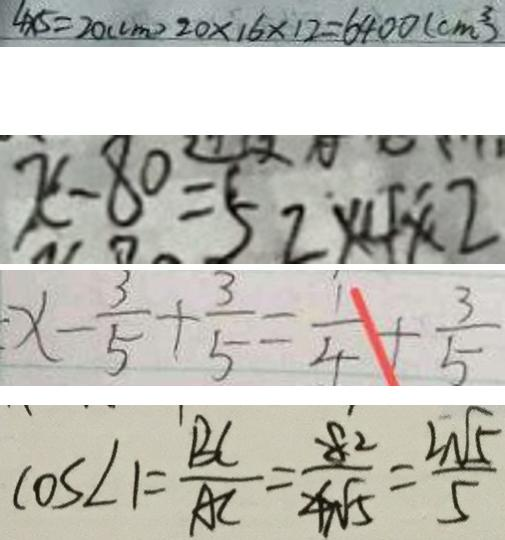Convert formula to latex. <formula><loc_0><loc_0><loc_500><loc_500>4 \times 5 = 2 0 ( c m ) 2 0 \times 1 6 \times 1 2 = 6 4 0 0 ( c m ^ { 3 } ) 
 x - 8 0 = 5 2 \times 4 \times 2 
 x - \frac { 3 } { 5 } + \frac { 3 } { 5 } = \frac { 1 } { 4 } + \frac { 3 } { 5 } 
 \cos \angle 1 = \frac { B C } { A C } = \frac { 8 ^ { 2 } } { 4 \sqrt { 5 } } = \frac { 2 \sqrt { 5 } } { 5 }</formula> 